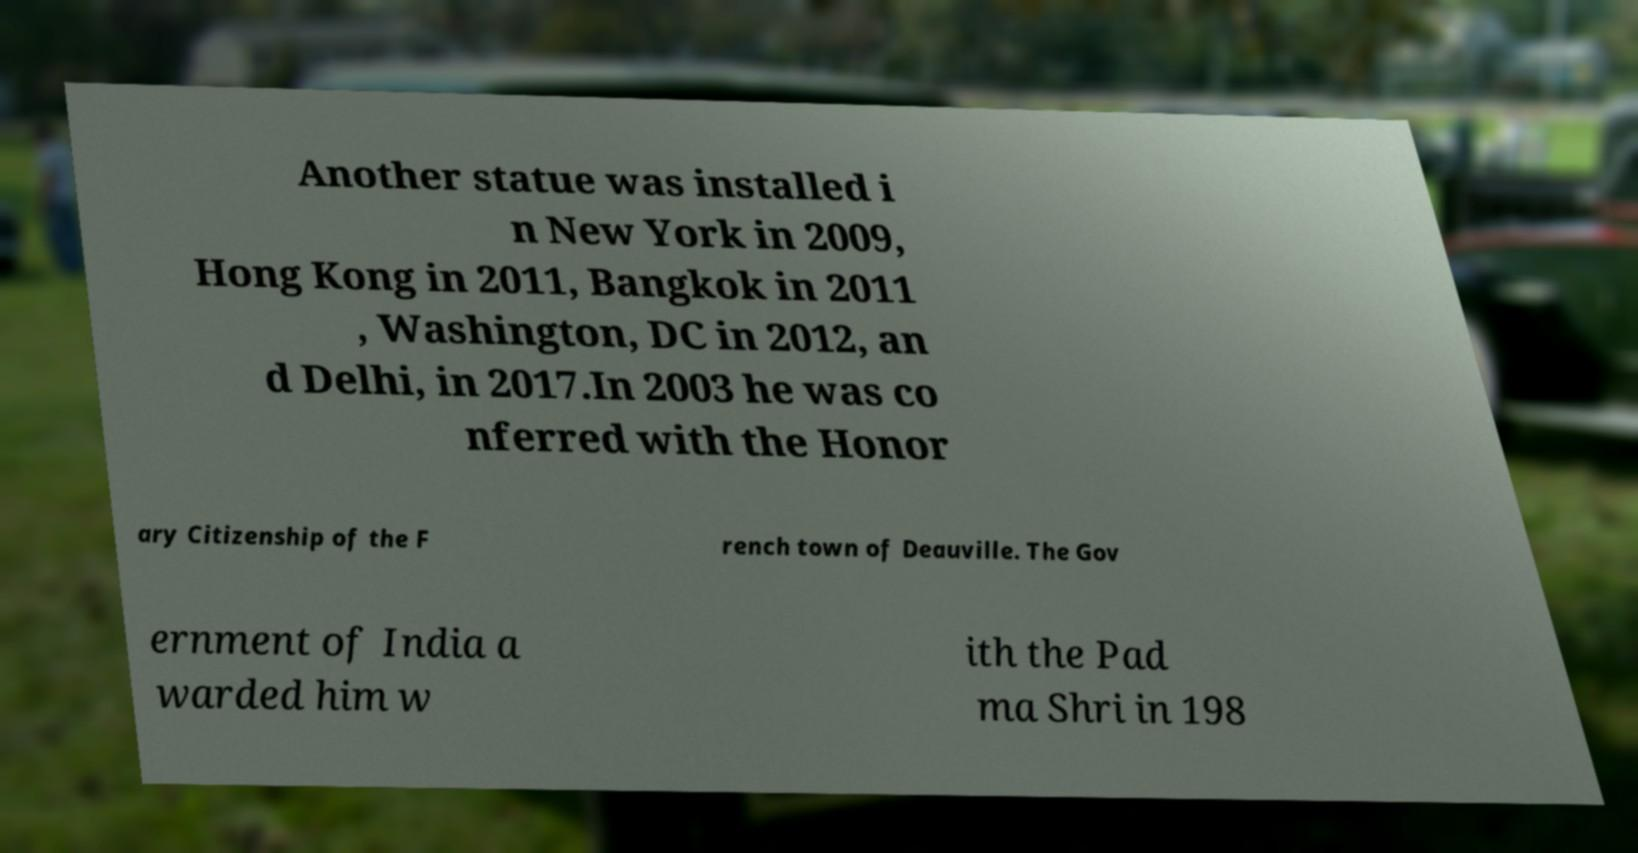Please identify and transcribe the text found in this image. Another statue was installed i n New York in 2009, Hong Kong in 2011, Bangkok in 2011 , Washington, DC in 2012, an d Delhi, in 2017.In 2003 he was co nferred with the Honor ary Citizenship of the F rench town of Deauville. The Gov ernment of India a warded him w ith the Pad ma Shri in 198 